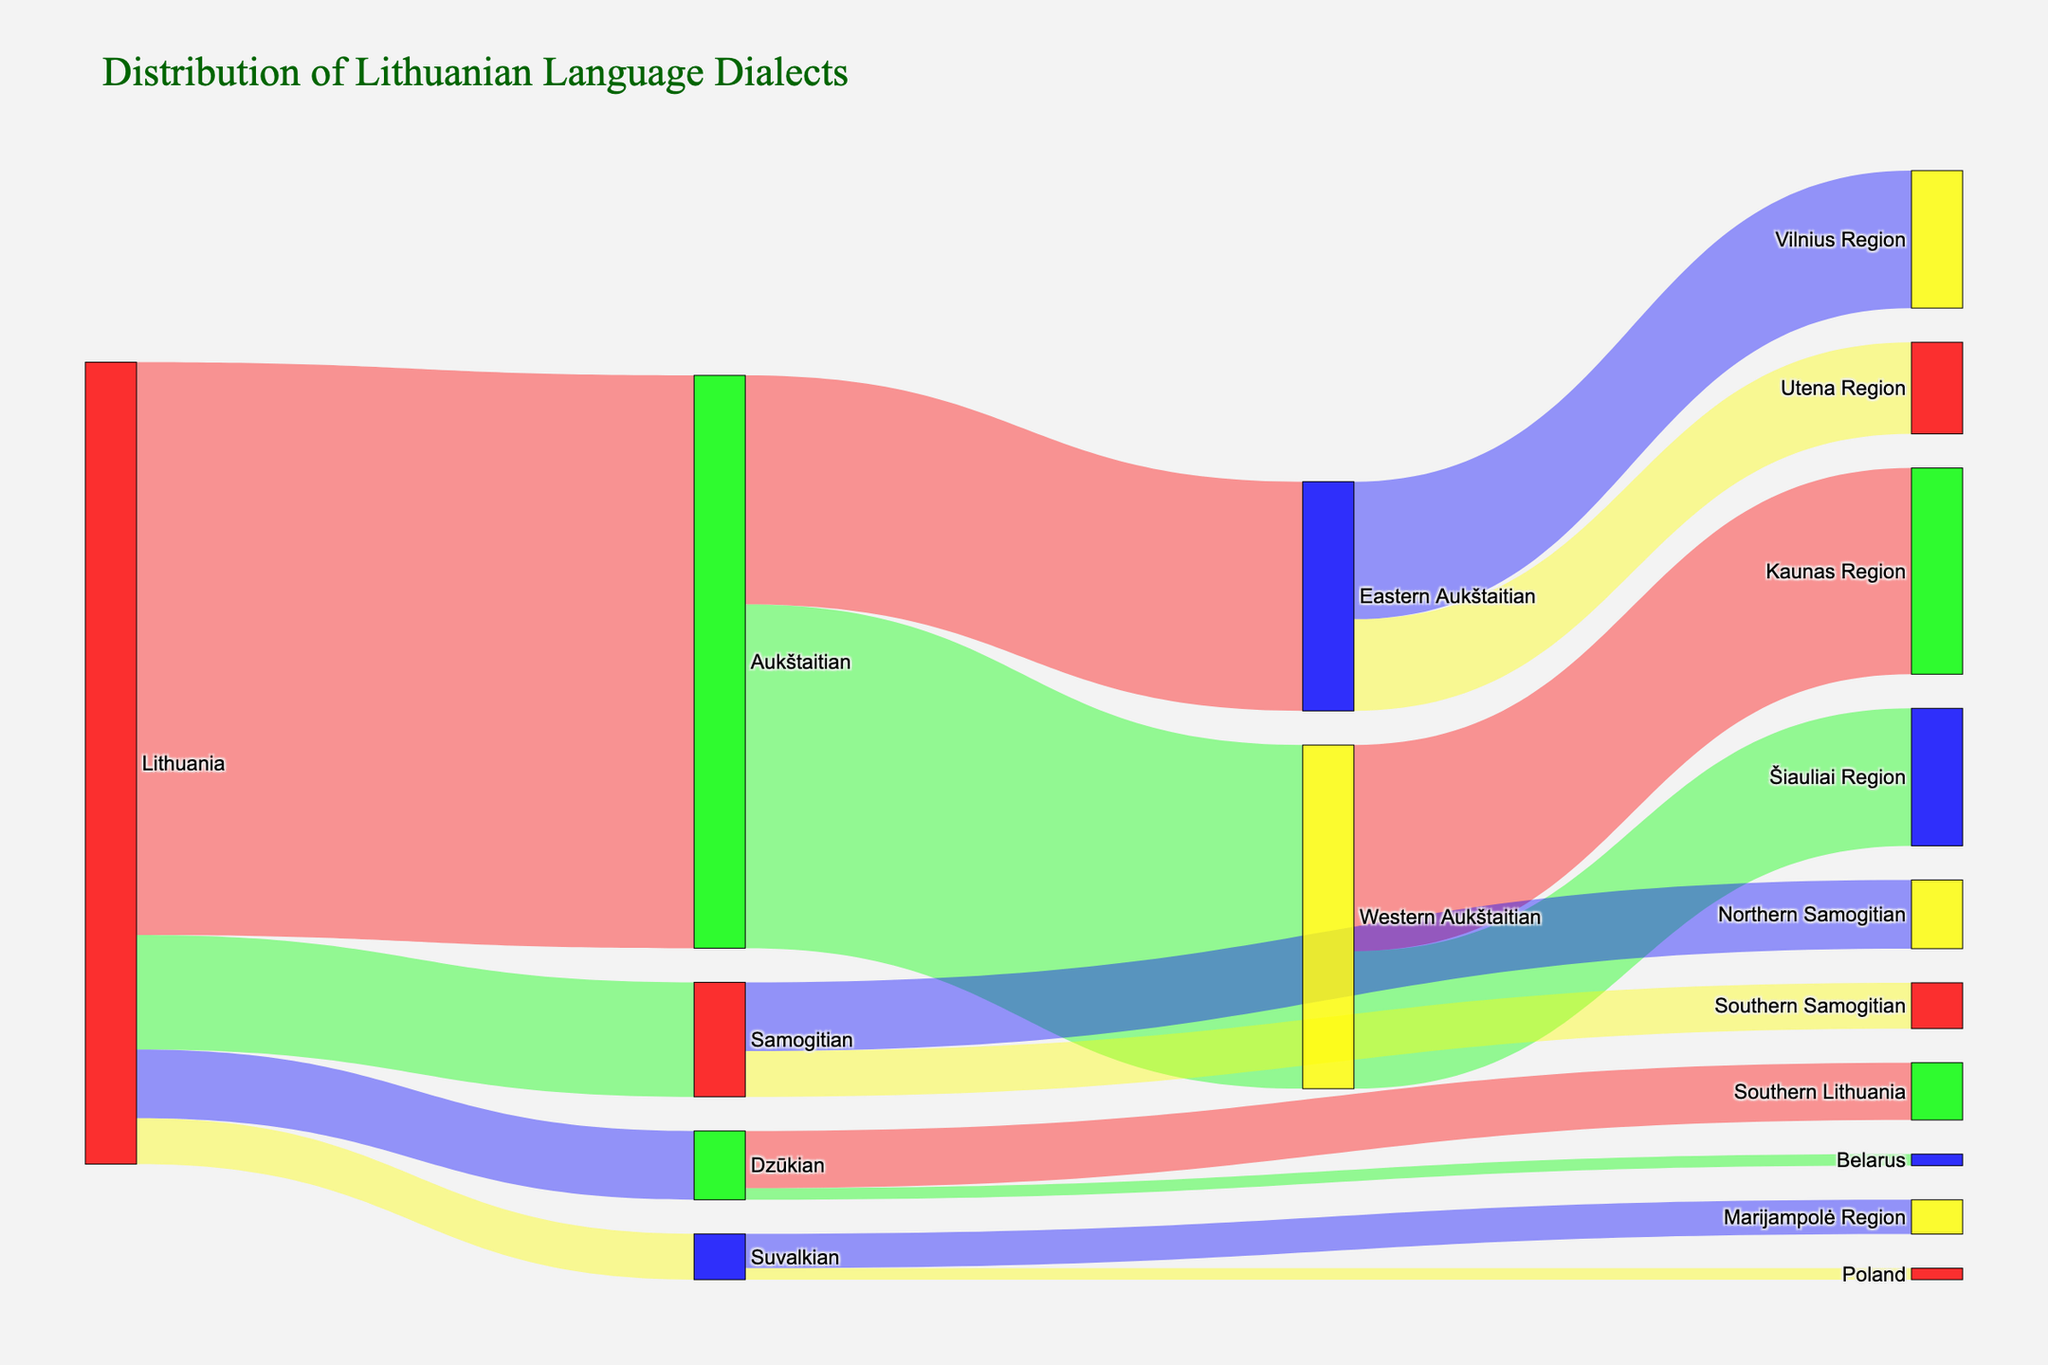Which dialect has the highest number of speakers in Lithuania? The largest number emanating from "Lithuania" in the diagram represents the Aukštaitian dialect with 2,500,000.
Answer: Aukštaitian What is the total number of speakers of Samogitian dialect, including its sub-dialects? Sum the numbers of Northern Samogitian (300,000) and Southern Samogitian (200,000). 300,000 + 200,000 = 500,000
Answer: 500,000 Which regions have the highest number of Eastern Aukštaitian speakers? Examine the Sankey diagram from the Eastern Aukštaitian segment and note the connections to Vilnius Region (600,000) and Utena Region (400,000). The Vilnius Region has the highest number.
Answer: Vilnius Region What is the number of Suvalkian speakers residing outside Lithuania? Check the connections from Suvalkian, which direct to Poland (50,000).
Answer: 50,000 What is the overall number of Dzūkian speakers living outside Lithuania? Sum the figures for Dzūkian speakers in Belarus (50,000). No other outer connection is available.
Answer: 50,000 Considering all the dialects, which one has the least number of speakers within Lithuania? Compare the numbers associated with each dialect sourced from Lithuania. Suvalkian has the smallest figure, 200,000.
Answer: Suvalkian How many speakers are there in total for Western Aukštaitian and Samogitian dialects combined? Sum the values representing the two groups coming from Lithuania (Western Aukštaitian: 1,500,000 + Samogitian: 500,000). 1,500,000 + 500,000 = 2,000,000
Answer: 2,000,000 Which region has the fewest speakers of Western Aukštaitian dialect? Compare the Kaunas Region (900,000) to the Šiauliai Region (600,000); Šiauliai Region has fewer speakers.
Answer: Šiauliai Region 